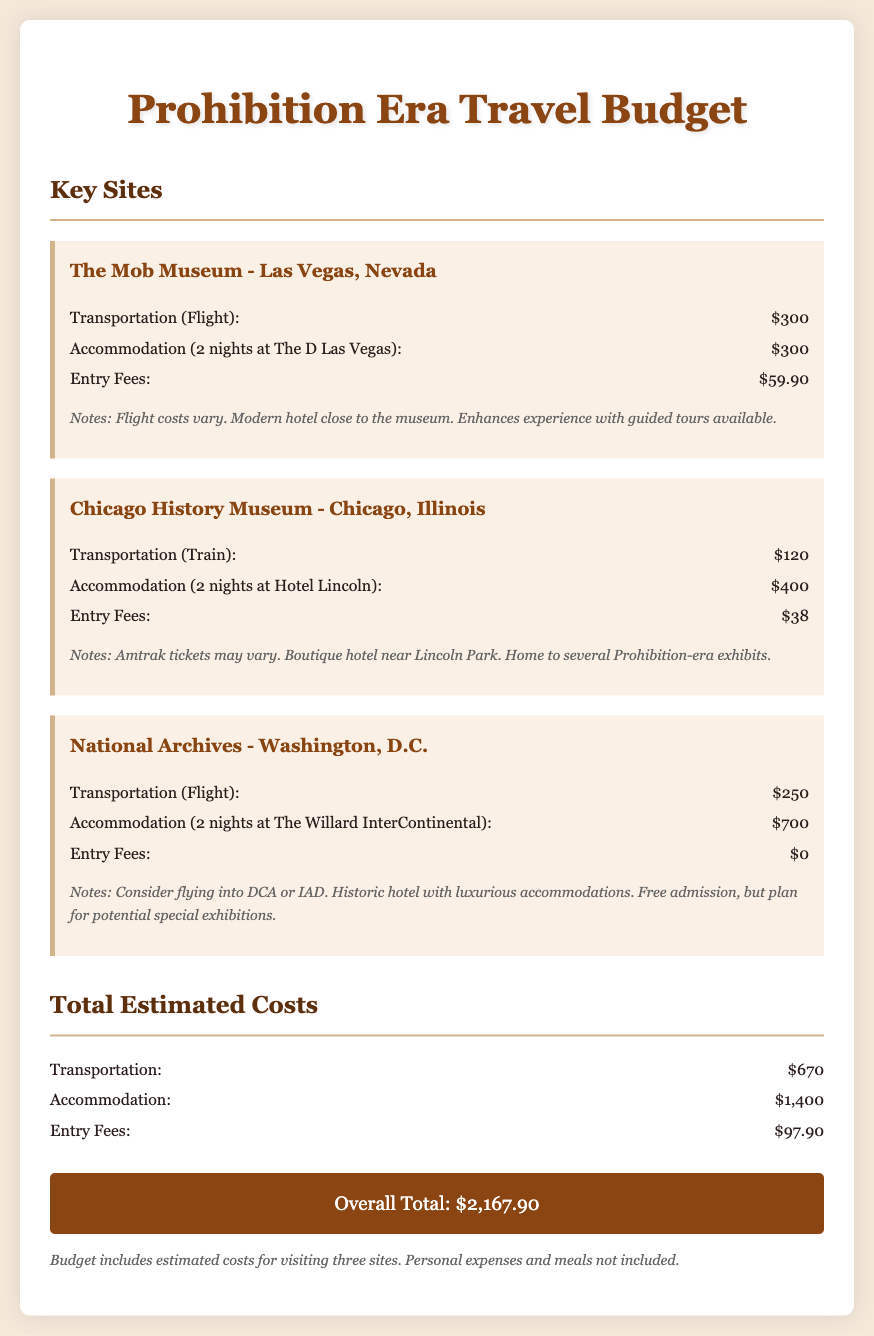What is the destination of The Mob Museum? The Mob Museum is located in Las Vegas, Nevada.
Answer: Las Vegas, Nevada How much do entry fees cost for the Chicago History Museum? The entry fees for the Chicago History Museum are stated directly in the document as $38.
Answer: $38 What is the total estimated cost for transportation? The document provides a breakdown of costs, and the total for transportation is $670.
Answer: $670 How many nights is the accommodation for The D Las Vegas? The accommodation for The D Las Vegas is for 2 nights, as specified in the document.
Answer: 2 nights Which historical site has no entry fees? The National Archives offers free admission, hence it has no entry fees mentioned in the document.
Answer: National Archives What is the overall total expense for the trip? The overall total, as calculated in the budget, is $2,167.90.
Answer: $2,167.90 Where is the Hotel Lincoln located? The Hotel Lincoln is located in Chicago, Illinois, according to the document.
Answer: Chicago, Illinois How much would a visitor pay for accommodation at The Willard InterContinental? The accommodation cost at The Willard InterContinental is clearly stated as $700 for 2 nights.
Answer: $700 What kind of hotel is The D Las Vegas described as? The D Las Vegas is described as a modern hotel, enhancing the visitor's experience.
Answer: Modern hotel 